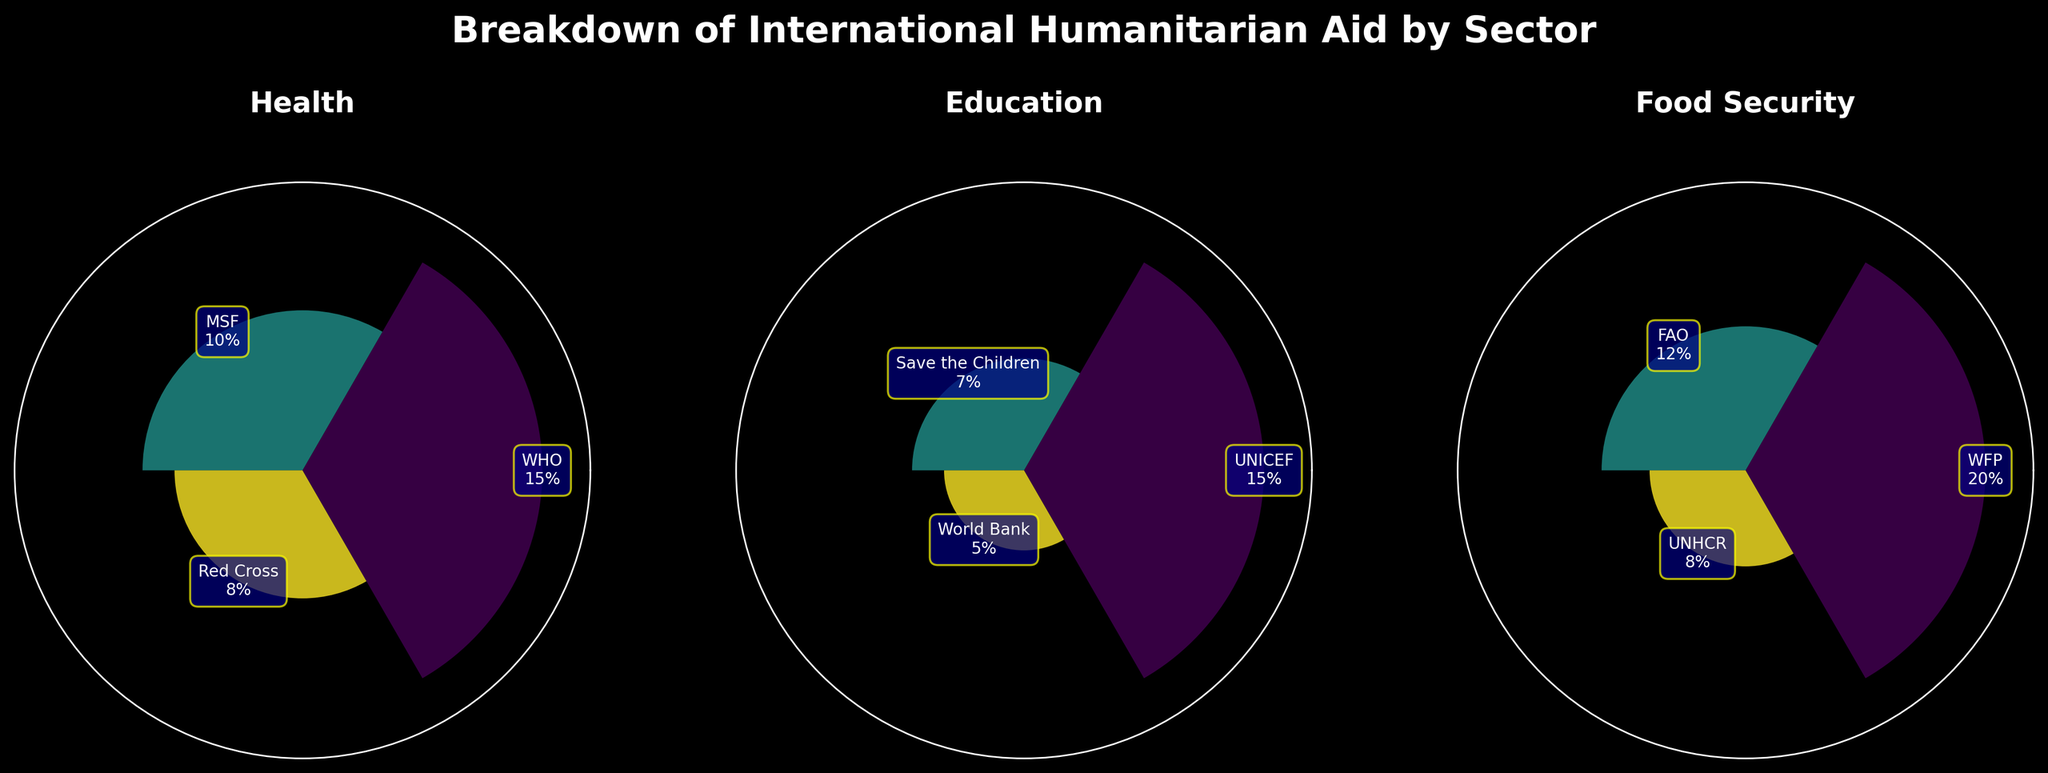What's the title of the figure? The title of the figure is displayed at the top in bold font as "Breakdown of International Humanitarian Aid by Sector".
Answer: Breakdown of International Humanitarian Aid by Sector How many sectors are represented in the figure? By counting the unique subplot titles, we can see that there are three unique sectors represented: Health, Education, and Food Security.
Answer: 3 Which entity has the highest percentage contribution in the Food Security sector? In the Food Security subplot, the entity bars can be observed, and the tallest bar represents WFP with a 20% contribution.
Answer: WFP What is the combined percentage of contributions by the UNHCR and Red Cross? In the Food Security subplot, UNHCR contributes 8%, and in the Health subplot, Red Cross contributes 8%. The combined contribution is 8% + 8% = 16%.
Answer: 16% Which sector has the highest total percentage contribution? By summing up the individual contributions in each sector: Health (15% + 10% + 8% = 33%), Education (15% + 7% + 5% = 27%), and Food Security (20% + 12% + 8% = 40%), we find that Food Security has the highest total percentage contribution.
Answer: Food Security How many entities contribute to the Education sector? By counting the labels on the bars in the Education subplot, we find that there are three contributing entities: UNICEF, Save the Children, and World Bank.
Answer: 3 Which sector has the smallest variance in percentage contributions among its entities? By observing the sectors: Health (15%, 10%, 8%), Education (15%, 7%, 5%), and Food Security (20%, 12%, 8%), and calculating the variance, Health has the smallest spread (15 - 8 = 7).
Answer: Health Is there a significant difference in the largest and smallest contributions in the Health sector? In the Health subplot, the largest contribution is WHO with 15%, and the smallest contribution is Red Cross with 8%. The difference is 15% - 8% = 7%.
Answer: Yes, 7% difference What is the average percentage contribution for entities in the Education sector? By adding the contributions in the Education sector (15% + 7% + 5%) and dividing by the number of entities (3), we get an average of (15% + 7% + 5%) / 3 = 9%.
Answer: 9% Which sector's entities have both the highest and lowest contributions when compared to entities of other sectors? Reviewing all sectors: the highest contribution is WFP in Food Security (20%) and the lowest contribution is World Bank in Education (5%). Thus, Food Security and Education sectors have both the highest and lowest contributing entities respectively.
Answer: Food Security and Education 